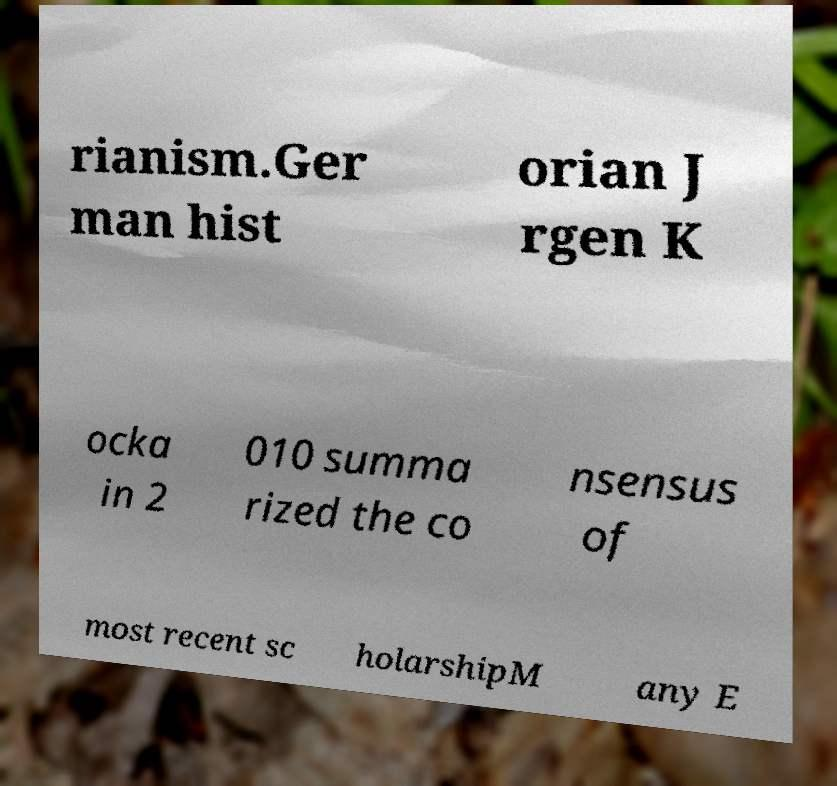For documentation purposes, I need the text within this image transcribed. Could you provide that? rianism.Ger man hist orian J rgen K ocka in 2 010 summa rized the co nsensus of most recent sc holarshipM any E 